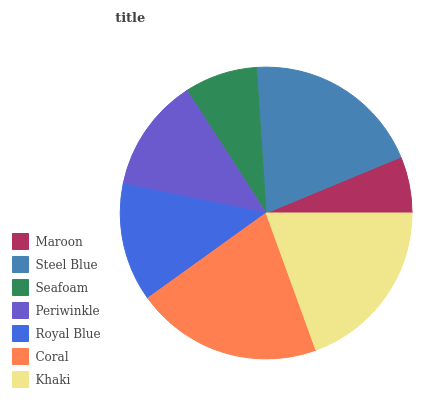Is Maroon the minimum?
Answer yes or no. Yes. Is Coral the maximum?
Answer yes or no. Yes. Is Steel Blue the minimum?
Answer yes or no. No. Is Steel Blue the maximum?
Answer yes or no. No. Is Steel Blue greater than Maroon?
Answer yes or no. Yes. Is Maroon less than Steel Blue?
Answer yes or no. Yes. Is Maroon greater than Steel Blue?
Answer yes or no. No. Is Steel Blue less than Maroon?
Answer yes or no. No. Is Royal Blue the high median?
Answer yes or no. Yes. Is Royal Blue the low median?
Answer yes or no. Yes. Is Seafoam the high median?
Answer yes or no. No. Is Khaki the low median?
Answer yes or no. No. 